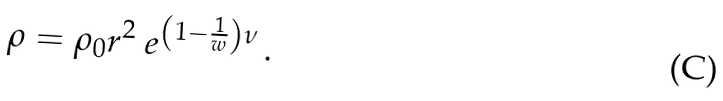Convert formula to latex. <formula><loc_0><loc_0><loc_500><loc_500>\rho = \rho _ { 0 } r ^ { 2 } \ e ^ { \left ( 1 - \frac { 1 } { w } \right ) \nu } \, .</formula> 